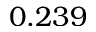<formula> <loc_0><loc_0><loc_500><loc_500>0 . 2 3 9</formula> 